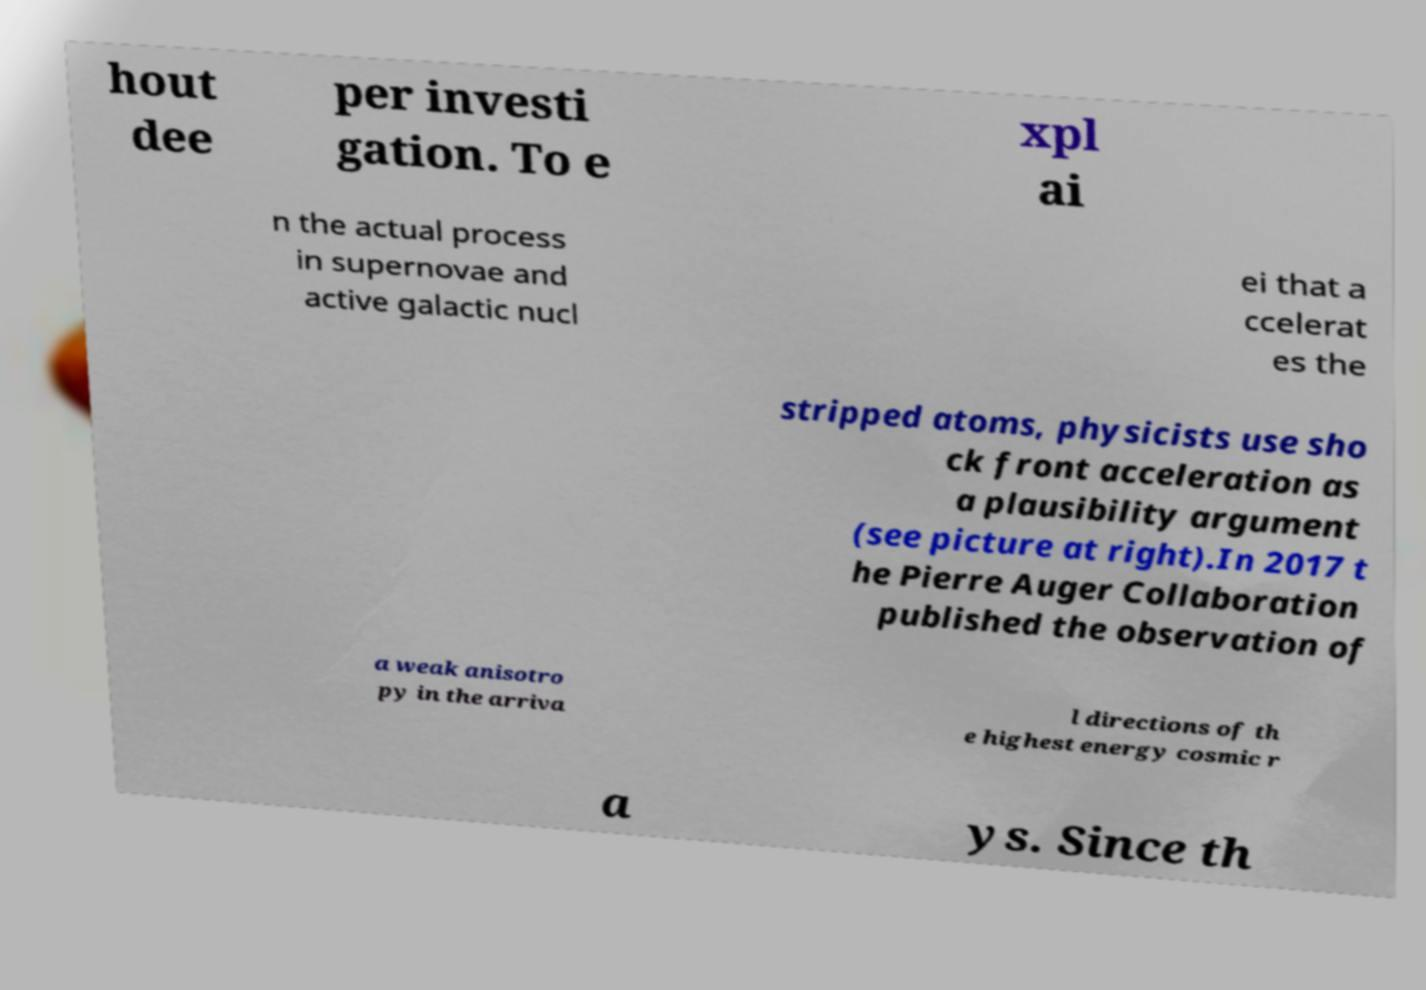What messages or text are displayed in this image? I need them in a readable, typed format. hout dee per investi gation. To e xpl ai n the actual process in supernovae and active galactic nucl ei that a ccelerat es the stripped atoms, physicists use sho ck front acceleration as a plausibility argument (see picture at right).In 2017 t he Pierre Auger Collaboration published the observation of a weak anisotro py in the arriva l directions of th e highest energy cosmic r a ys. Since th 